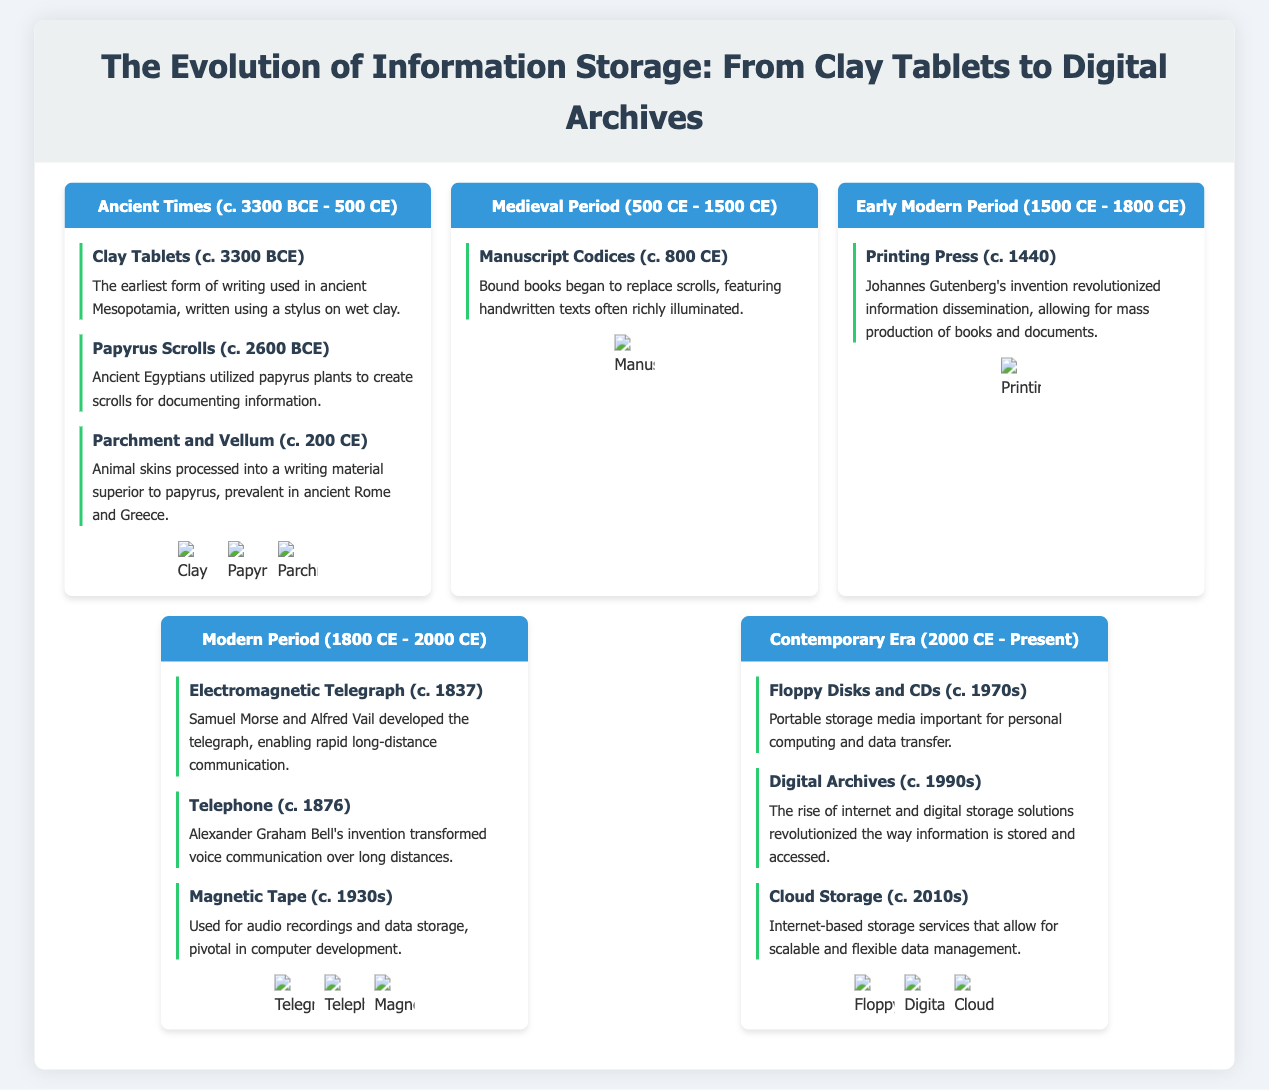What was the earliest form of writing? The document states that clay tablets were the earliest form of writing used in ancient Mesopotamia.
Answer: Clay Tablets When were papyrus scrolls utilized? According to the timeline in the infographic, papyrus scrolls were created around 2600 BCE.
Answer: c. 2600 BCE Who invented the printing press? The document mentions Johannes Gutenberg as the inventor of the printing press around 1440.
Answer: Johannes Gutenberg What year was the electromagnetic telegraph developed? The infographic states that the electromagnetic telegraph was developed around 1837.
Answer: c. 1837 What information storage medium emerged in the 1990s? The document identifies digital archives as a significant advancement in the 1990s.
Answer: Digital Archives Which storage technology appeared in the 1970s? The infographic lists floppy disks and CDs as important storage media that emerged during the 1970s.
Answer: Floppy Disks and CDs What did manuscript codices replace? According to the document, manuscript codices began to replace scrolls.
Answer: Scrolls How did cloud storage change data management? The infographic highlights that cloud storage allows for scalable and flexible data management.
Answer: Scalable and flexible data management Which period featured the use of parchment and vellum? The document states that parchment and vellum were commonly used around 200 CE in ancient Rome and Greece.
Answer: c. 200 CE 